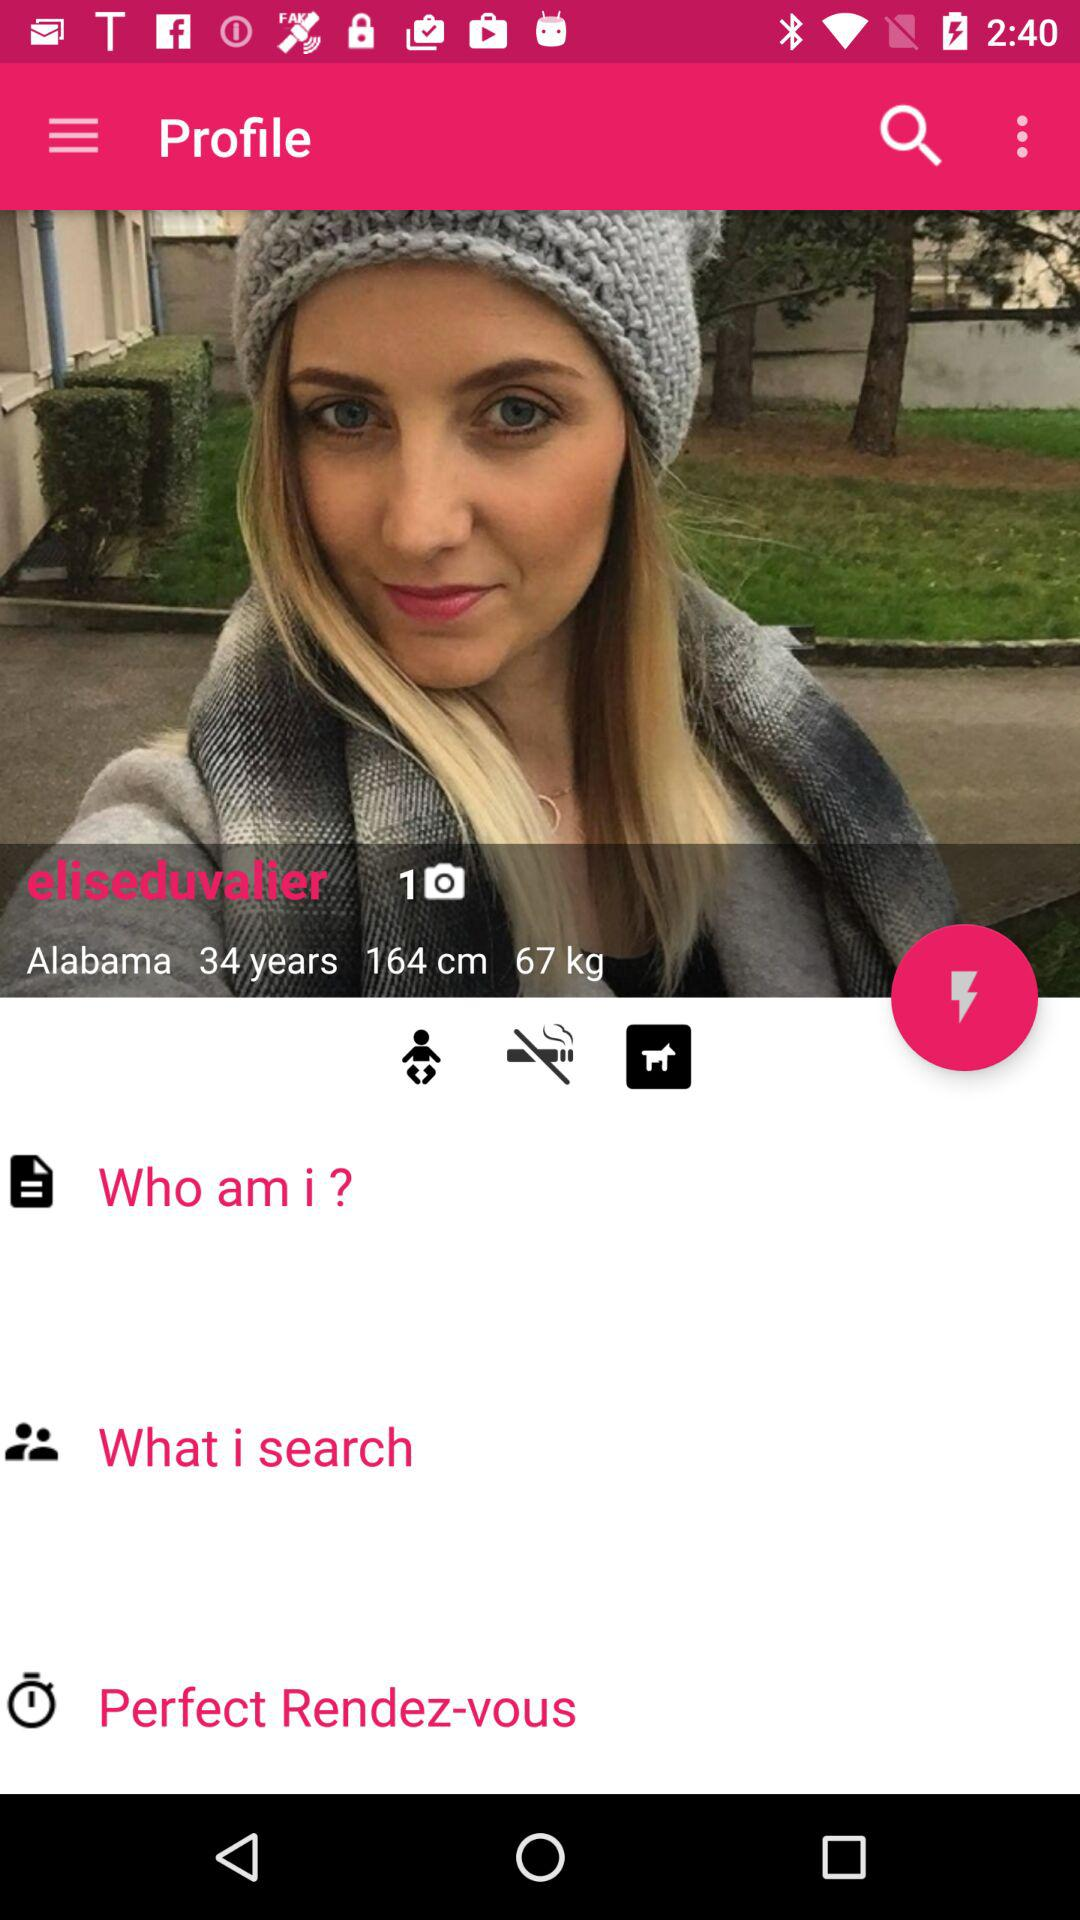What weight does she have? The weight is 67 kg. 